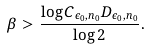Convert formula to latex. <formula><loc_0><loc_0><loc_500><loc_500>\beta > \frac { \log C _ { \epsilon _ { 0 } , n _ { 0 } } D _ { \epsilon _ { 0 } , n _ { 0 } } } { \log 2 } .</formula> 